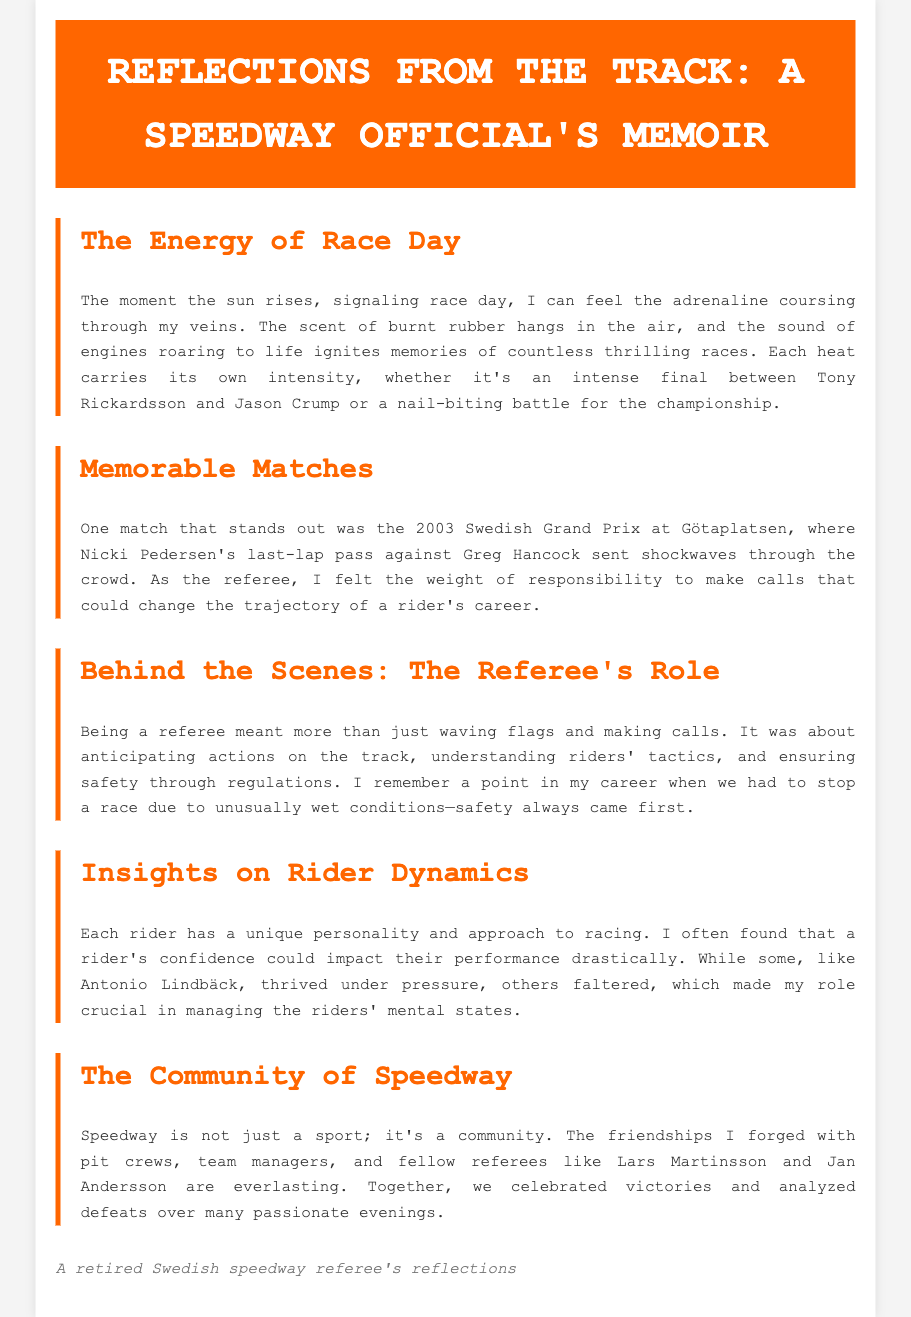What notable event happened during the 2003 Swedish Grand Prix? The document mentions Nicki Pedersen's last-lap pass against Greg Hancock, which was a significant moment in the race.
Answer: Last-lap pass against Greg Hancock What is the primary responsibility of a speedway referee? According to the document, a referee's role involves making calls, anticipating actions on the track, and ensuring safety through regulations.
Answer: Ensuring safety Which riders are specifically mentioned in the document? The document highlights several riders, including Tony Rickardsson, Jason Crump, Nicki Pedersen, Greg Hancock, Antonio Lindbäck, Lars Martinsson, and Jan Andersson.
Answer: Tony Rickardsson, Jason Crump, Nicki Pedersen, Greg Hancock, Antonio Lindbäck, Lars Martinsson, Jan Andersson What does the author associate with the scent of burnt rubber? The author connects the scent of burnt rubber with the excitement and memories of race day.
Answer: Excitement and memories In what conditions did the author mention having to stop a race? The author notes they had to stop a race due to unusually wet conditions.
Answer: Unusually wet conditions How does the author describe the community of speedway? The document describes the speedway community as one that involves friendships and shared experiences among teams, pit crews, and referees.
Answer: A community of friendships and shared experiences What was the author's career position in speedway? The author identifies themselves as a referee in the realm of speedway racing.
Answer: Referee What psychological impact can a rider's confidence have, according to the author? The author states that a rider's confidence significantly impacts their performance during races.
Answer: Significantly impacts performance 